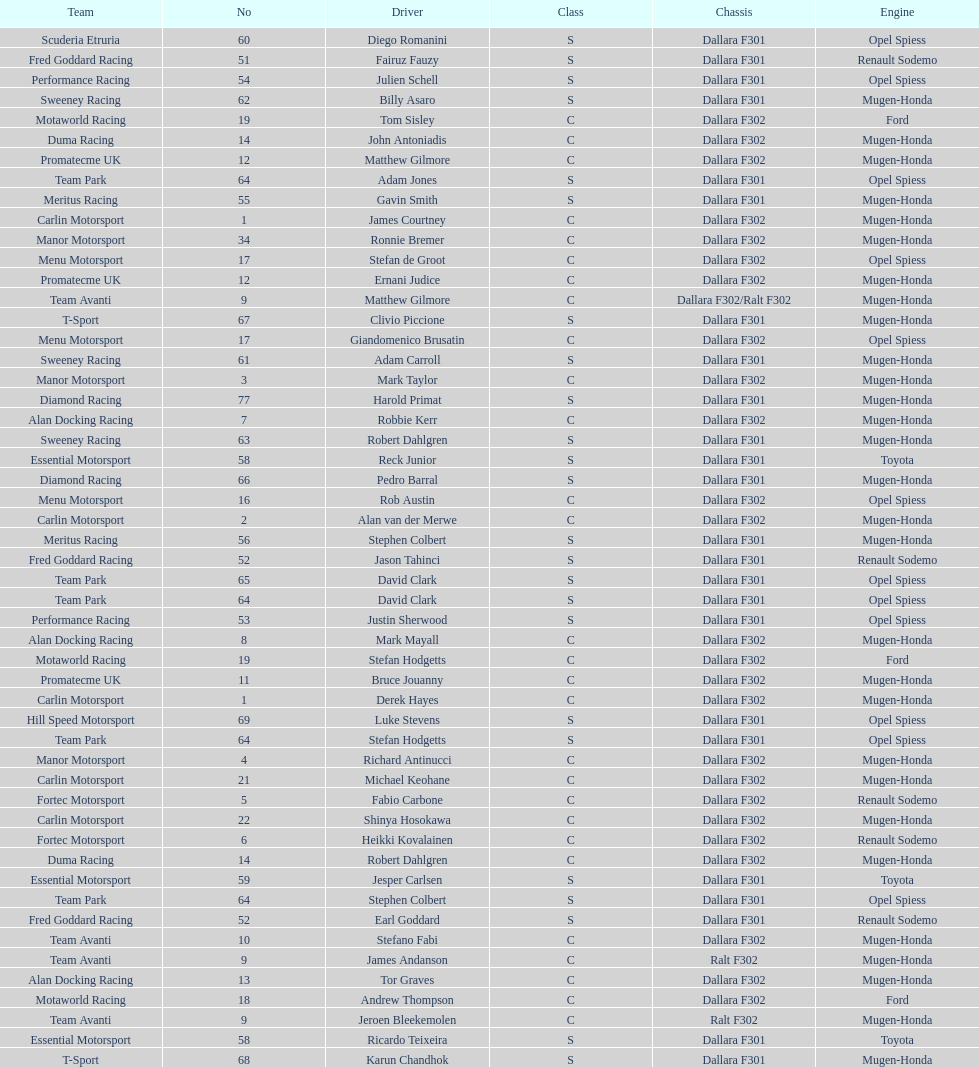What team is listed above diamond racing? Team Park. 